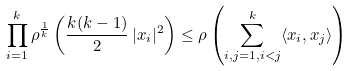Convert formula to latex. <formula><loc_0><loc_0><loc_500><loc_500>\prod _ { i = 1 } ^ { k } \rho ^ { \frac { 1 } { k } } \left ( \frac { k ( k - 1 ) } { 2 } \, | x _ { i } | ^ { 2 } \right ) \leq \rho \left ( \sum _ { i , j = 1 , i < j } ^ { k } \langle x _ { i } , x _ { j } \rangle \right )</formula> 